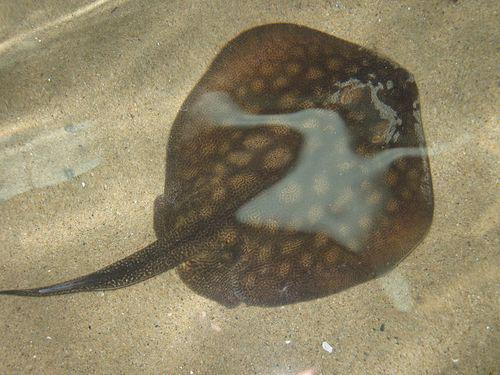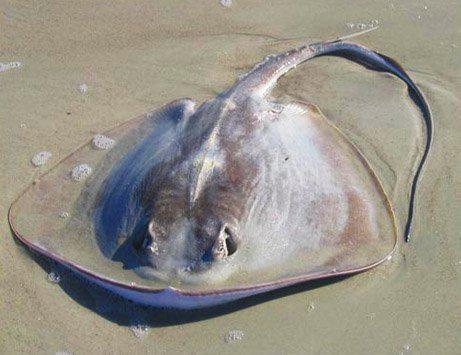The first image is the image on the left, the second image is the image on the right. Examine the images to the left and right. Is the description "All the rays are under water." accurate? Answer yes or no. No. 